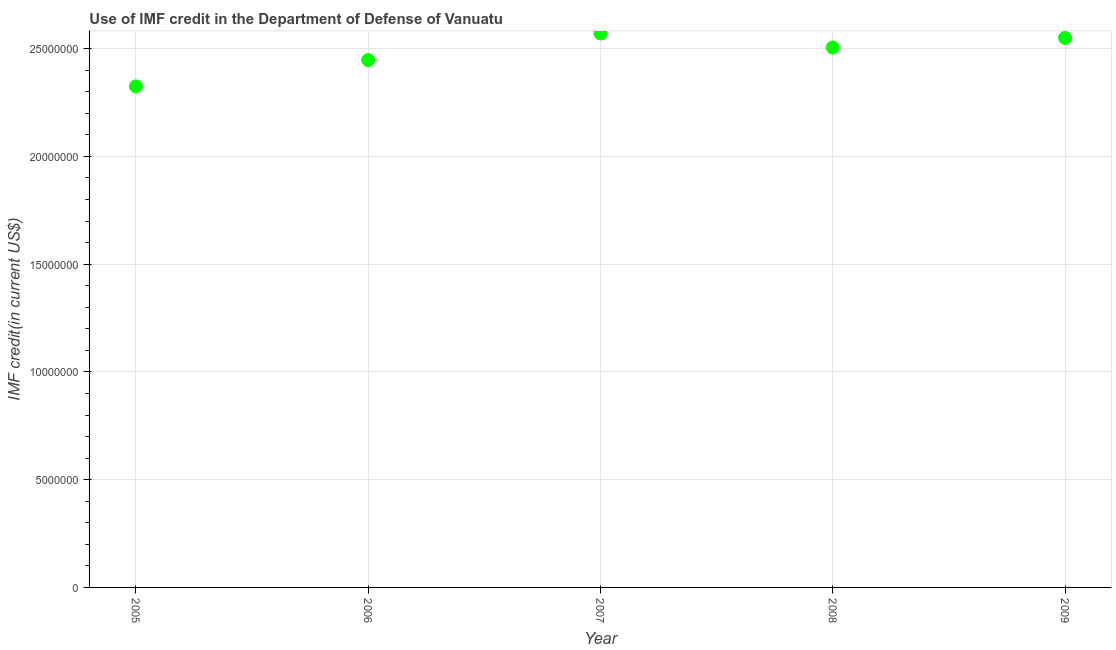What is the use of imf credit in dod in 2007?
Keep it short and to the point. 2.57e+07. Across all years, what is the maximum use of imf credit in dod?
Ensure brevity in your answer.  2.57e+07. Across all years, what is the minimum use of imf credit in dod?
Provide a succinct answer. 2.32e+07. What is the sum of the use of imf credit in dod?
Offer a terse response. 1.24e+08. What is the difference between the use of imf credit in dod in 2006 and 2008?
Ensure brevity in your answer.  -5.83e+05. What is the average use of imf credit in dod per year?
Your answer should be compact. 2.48e+07. What is the median use of imf credit in dod?
Your answer should be very brief. 2.51e+07. Do a majority of the years between 2006 and 2005 (inclusive) have use of imf credit in dod greater than 18000000 US$?
Your response must be concise. No. What is the ratio of the use of imf credit in dod in 2006 to that in 2009?
Give a very brief answer. 0.96. What is the difference between the highest and the second highest use of imf credit in dod?
Provide a short and direct response. 2.05e+05. What is the difference between the highest and the lowest use of imf credit in dod?
Offer a very short reply. 2.46e+06. In how many years, is the use of imf credit in dod greater than the average use of imf credit in dod taken over all years?
Your answer should be very brief. 3. Does the use of imf credit in dod monotonically increase over the years?
Your response must be concise. No. How many dotlines are there?
Ensure brevity in your answer.  1. Are the values on the major ticks of Y-axis written in scientific E-notation?
Your answer should be very brief. No. Does the graph contain any zero values?
Your answer should be very brief. No. What is the title of the graph?
Make the answer very short. Use of IMF credit in the Department of Defense of Vanuatu. What is the label or title of the X-axis?
Make the answer very short. Year. What is the label or title of the Y-axis?
Your answer should be very brief. IMF credit(in current US$). What is the IMF credit(in current US$) in 2005?
Offer a terse response. 2.32e+07. What is the IMF credit(in current US$) in 2006?
Provide a succinct answer. 2.45e+07. What is the IMF credit(in current US$) in 2007?
Your response must be concise. 2.57e+07. What is the IMF credit(in current US$) in 2008?
Ensure brevity in your answer.  2.51e+07. What is the IMF credit(in current US$) in 2009?
Ensure brevity in your answer.  2.55e+07. What is the difference between the IMF credit(in current US$) in 2005 and 2006?
Your answer should be very brief. -1.22e+06. What is the difference between the IMF credit(in current US$) in 2005 and 2007?
Your answer should be very brief. -2.46e+06. What is the difference between the IMF credit(in current US$) in 2005 and 2008?
Provide a short and direct response. -1.80e+06. What is the difference between the IMF credit(in current US$) in 2005 and 2009?
Your answer should be compact. -2.25e+06. What is the difference between the IMF credit(in current US$) in 2006 and 2007?
Your answer should be very brief. -1.23e+06. What is the difference between the IMF credit(in current US$) in 2006 and 2008?
Your answer should be very brief. -5.83e+05. What is the difference between the IMF credit(in current US$) in 2006 and 2009?
Keep it short and to the point. -1.03e+06. What is the difference between the IMF credit(in current US$) in 2007 and 2008?
Offer a very short reply. 6.51e+05. What is the difference between the IMF credit(in current US$) in 2007 and 2009?
Your response must be concise. 2.05e+05. What is the difference between the IMF credit(in current US$) in 2008 and 2009?
Your response must be concise. -4.46e+05. What is the ratio of the IMF credit(in current US$) in 2005 to that in 2007?
Your answer should be compact. 0.9. What is the ratio of the IMF credit(in current US$) in 2005 to that in 2008?
Keep it short and to the point. 0.93. What is the ratio of the IMF credit(in current US$) in 2005 to that in 2009?
Make the answer very short. 0.91. What is the ratio of the IMF credit(in current US$) in 2006 to that in 2008?
Make the answer very short. 0.98. What is the ratio of the IMF credit(in current US$) in 2007 to that in 2009?
Provide a succinct answer. 1.01. 